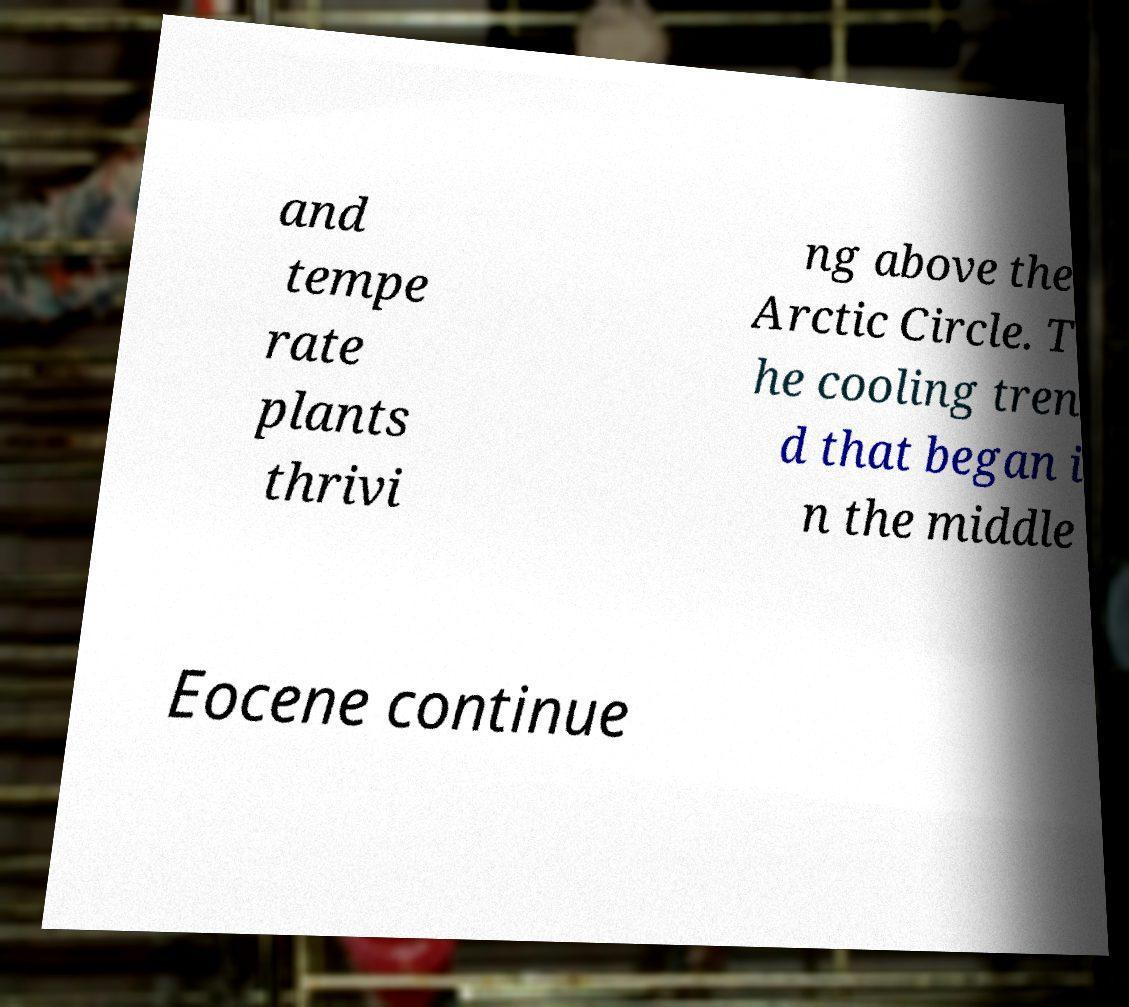Please read and relay the text visible in this image. What does it say? and tempe rate plants thrivi ng above the Arctic Circle. T he cooling tren d that began i n the middle Eocene continue 